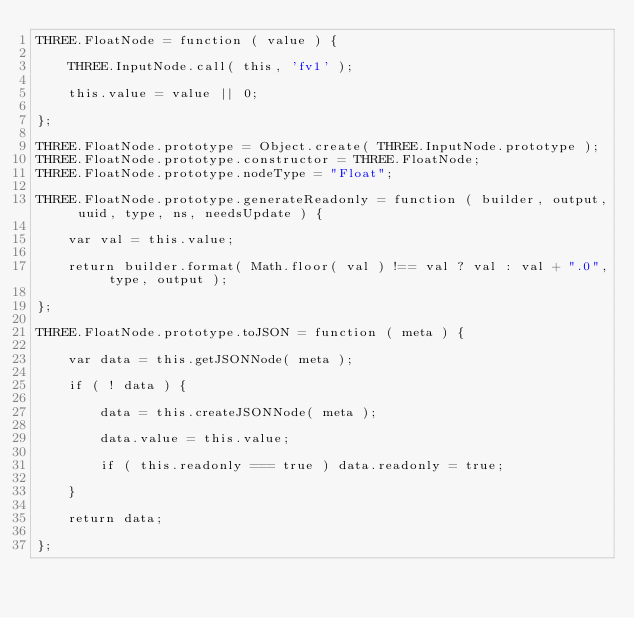Convert code to text. <code><loc_0><loc_0><loc_500><loc_500><_JavaScript_>THREE.FloatNode = function ( value ) {

	THREE.InputNode.call( this, 'fv1' );

	this.value = value || 0;

};

THREE.FloatNode.prototype = Object.create( THREE.InputNode.prototype );
THREE.FloatNode.prototype.constructor = THREE.FloatNode;
THREE.FloatNode.prototype.nodeType = "Float";

THREE.FloatNode.prototype.generateReadonly = function ( builder, output, uuid, type, ns, needsUpdate ) {

	var val = this.value;

	return builder.format( Math.floor( val ) !== val ? val : val + ".0", type, output );

};

THREE.FloatNode.prototype.toJSON = function ( meta ) {

	var data = this.getJSONNode( meta );

	if ( ! data ) {

		data = this.createJSONNode( meta );

		data.value = this.value;

		if ( this.readonly === true ) data.readonly = true;

	}

	return data;

};
</code> 